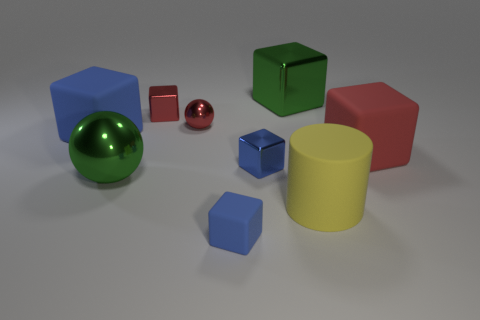Add 1 big spheres. How many objects exist? 10 Subtract all green cubes. How many cubes are left? 5 Subtract all green blocks. How many blocks are left? 5 Subtract all spheres. How many objects are left? 7 Subtract all green cylinders. Subtract all brown balls. How many cylinders are left? 1 Subtract all red cylinders. How many purple cubes are left? 0 Subtract all large purple rubber cylinders. Subtract all rubber things. How many objects are left? 5 Add 8 large shiny objects. How many large shiny objects are left? 10 Add 3 large green cubes. How many large green cubes exist? 4 Subtract 1 red spheres. How many objects are left? 8 